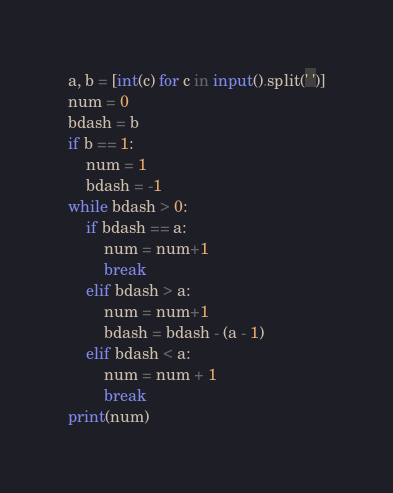<code> <loc_0><loc_0><loc_500><loc_500><_Python_>a, b = [int(c) for c in input().split(' ')]
num = 0
bdash = b
if b == 1:
    num = 1
    bdash = -1
while bdash > 0:
    if bdash == a:
        num = num+1
        break
    elif bdash > a:
        num = num+1
        bdash = bdash - (a - 1)
    elif bdash < a:
        num = num + 1
        break
print(num)
</code> 